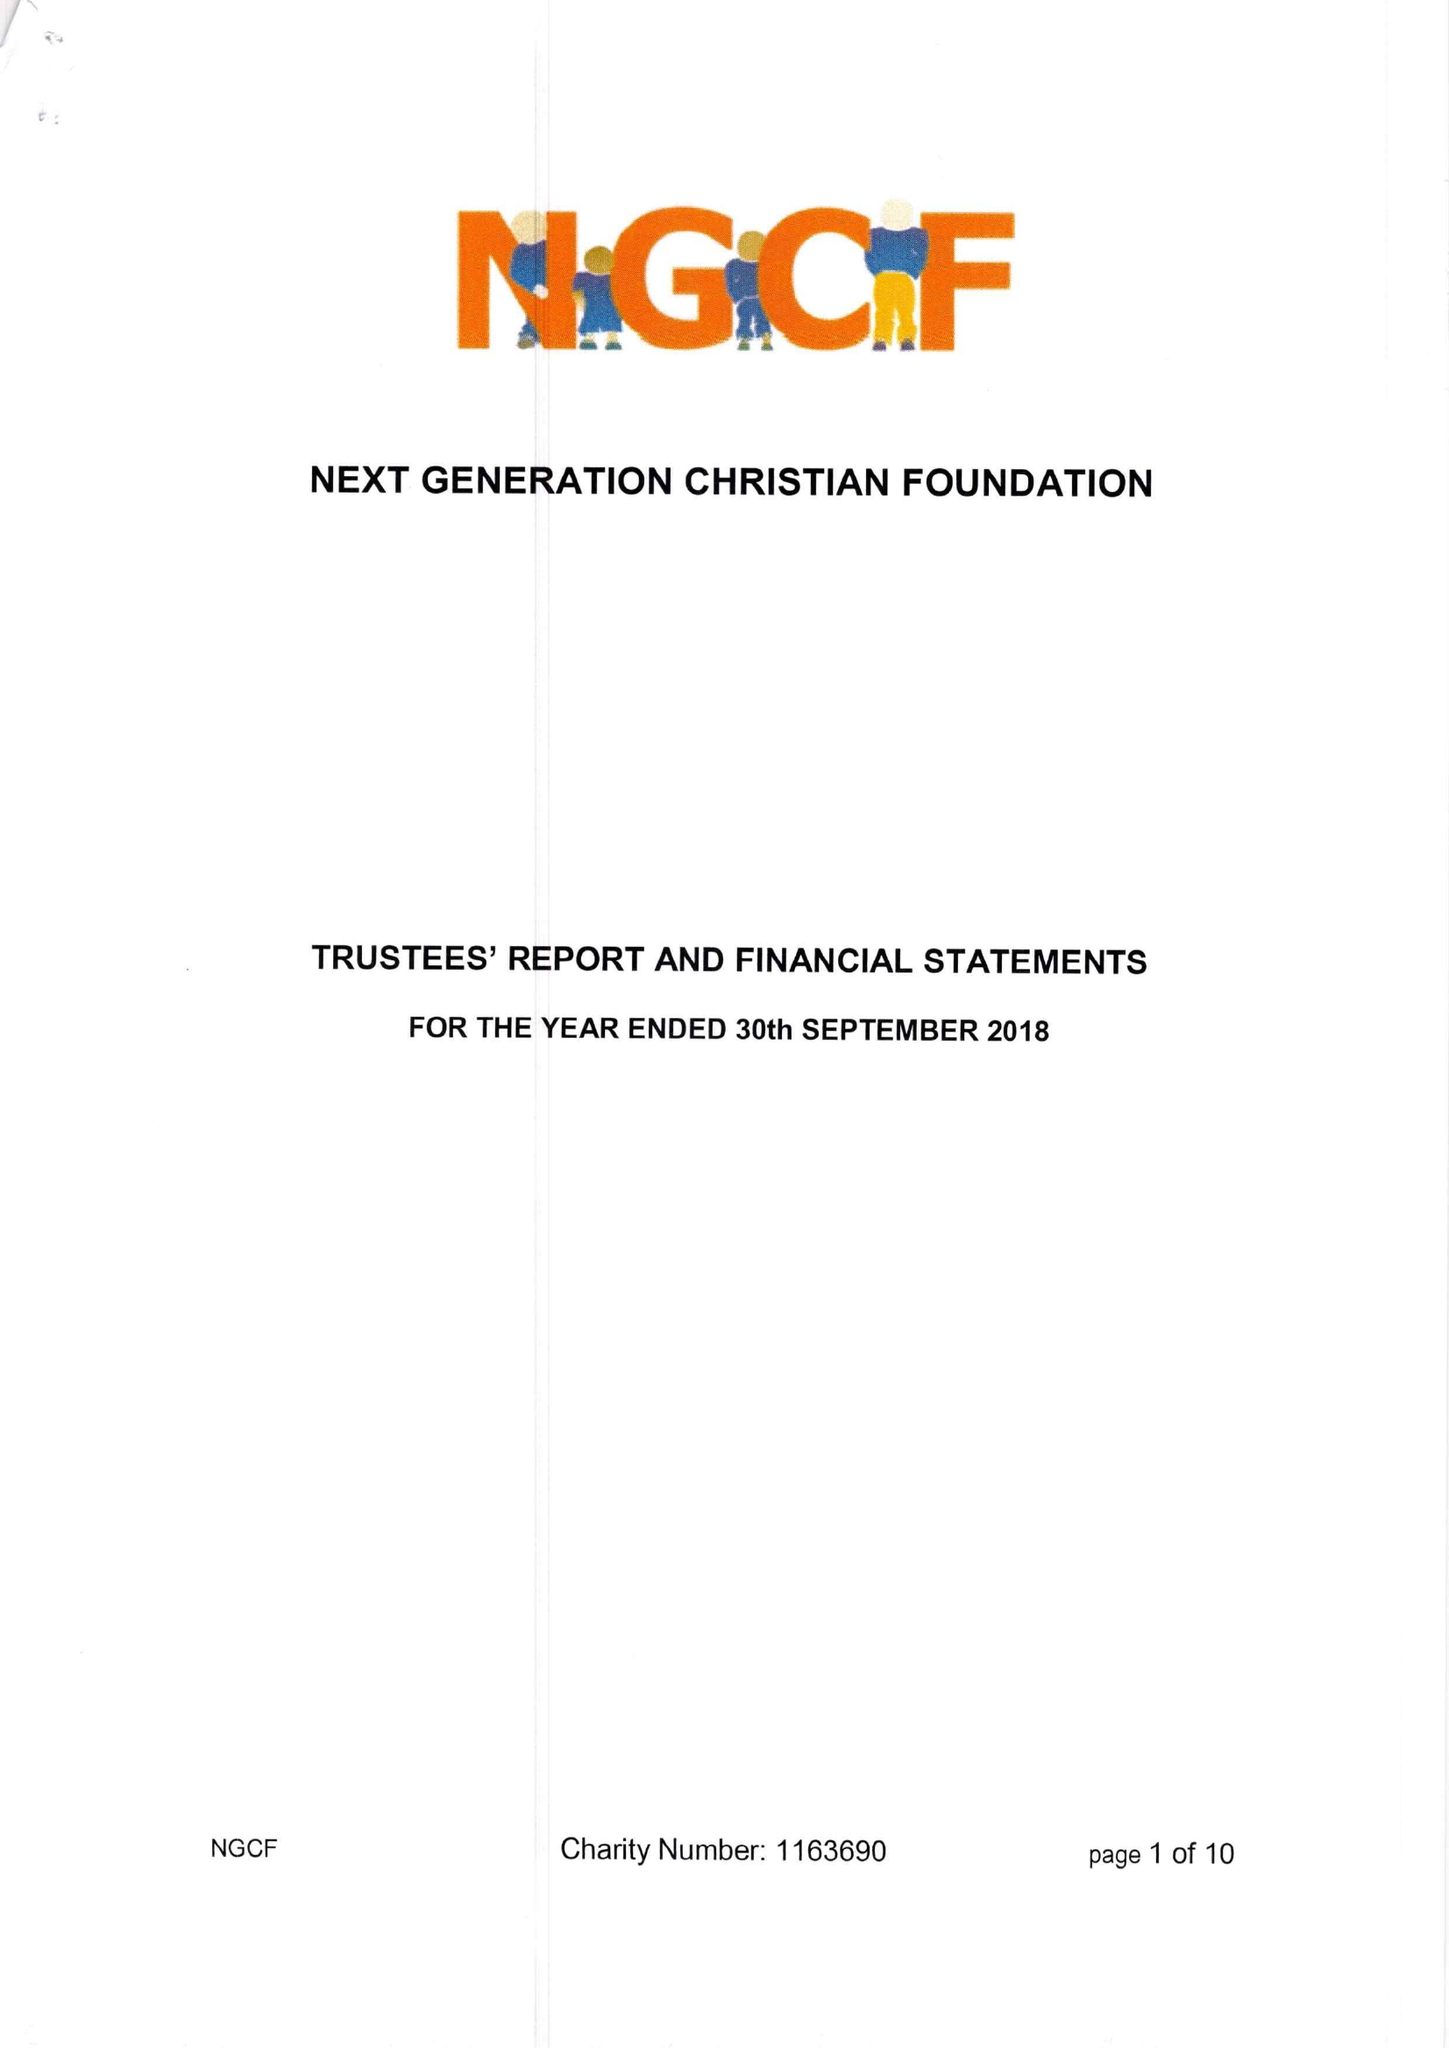What is the value for the charity_number?
Answer the question using a single word or phrase. 1163690 